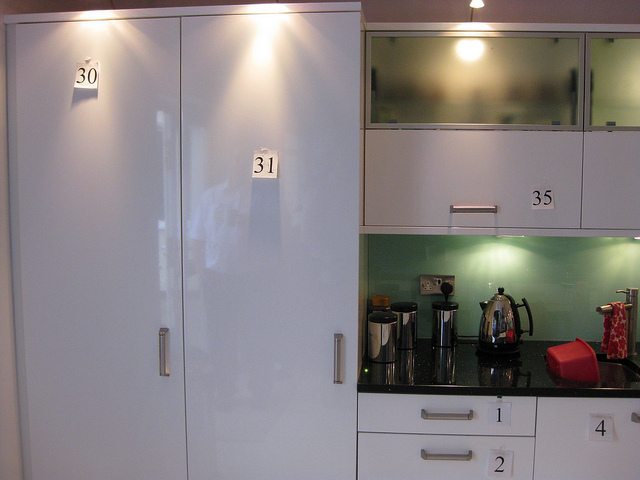Please transcribe the text in this image. 30 31 35 2 4 1 